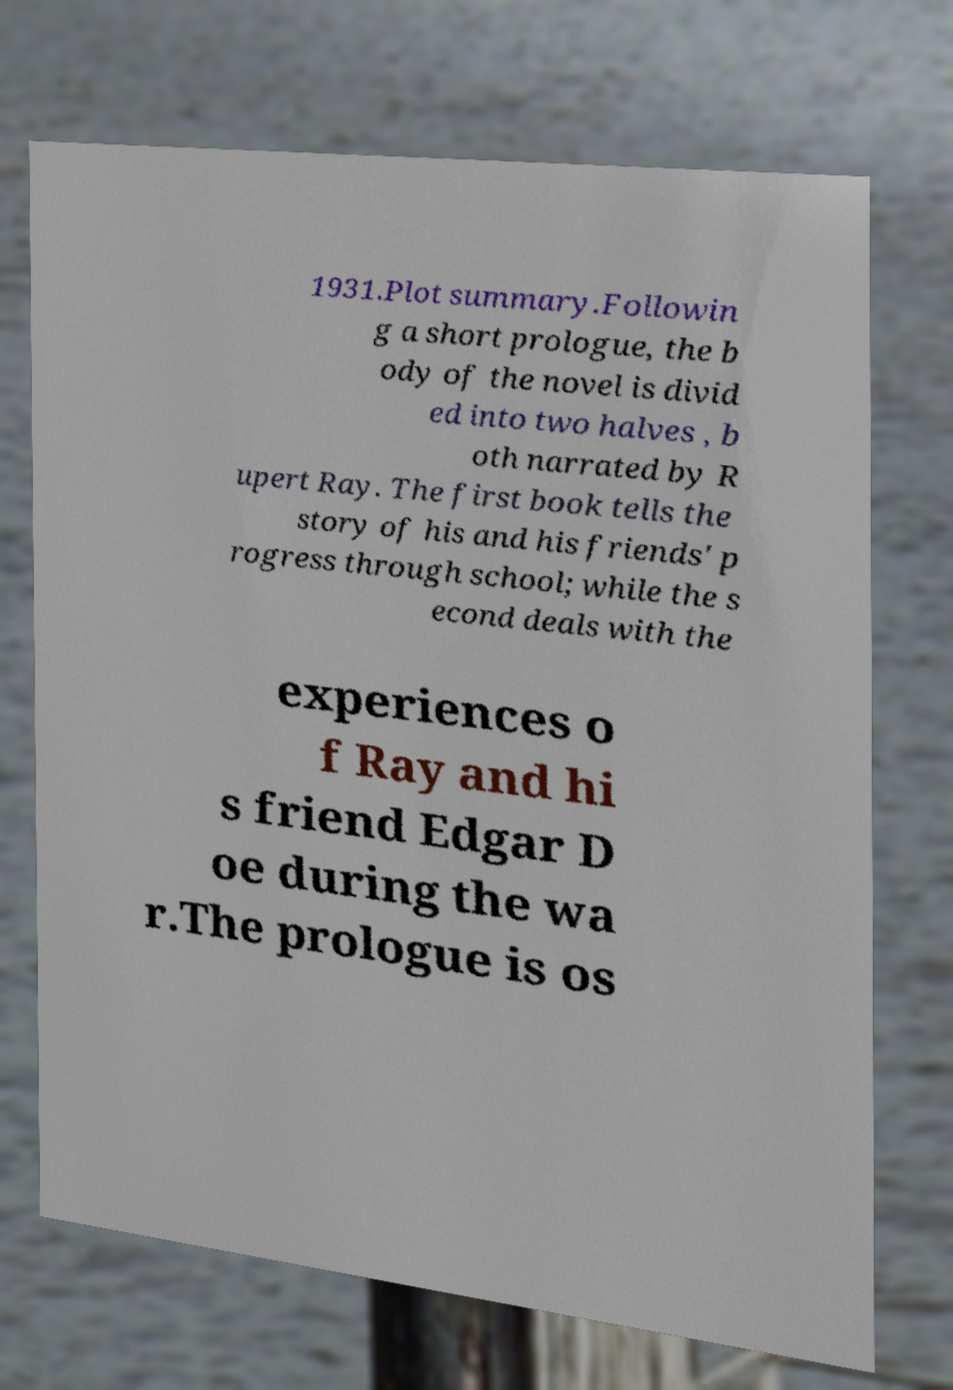Please read and relay the text visible in this image. What does it say? 1931.Plot summary.Followin g a short prologue, the b ody of the novel is divid ed into two halves , b oth narrated by R upert Ray. The first book tells the story of his and his friends' p rogress through school; while the s econd deals with the experiences o f Ray and hi s friend Edgar D oe during the wa r.The prologue is os 